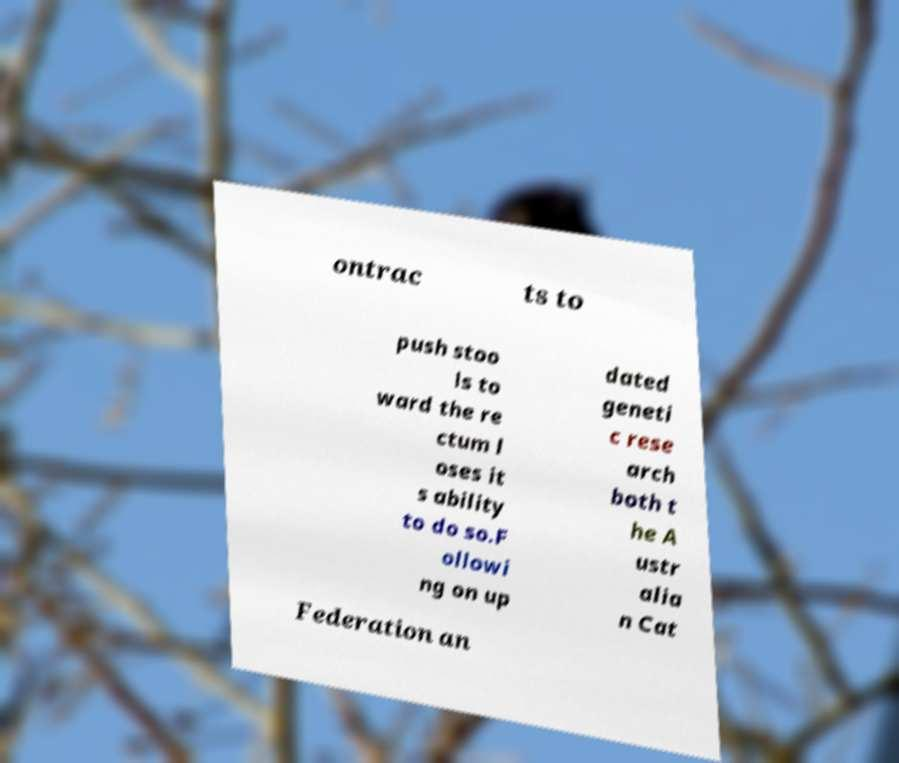What messages or text are displayed in this image? I need them in a readable, typed format. ontrac ts to push stoo ls to ward the re ctum l oses it s ability to do so.F ollowi ng on up dated geneti c rese arch both t he A ustr alia n Cat Federation an 